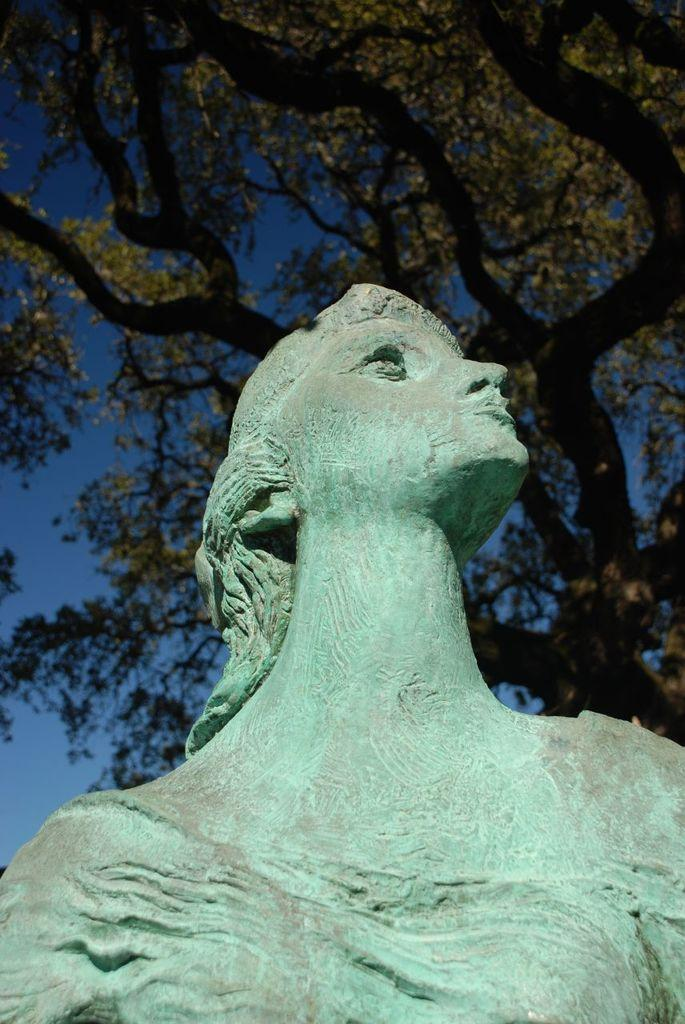What is the main subject in the image? There is a sculpture in the image. What can be seen in the background of the image? There is a tree in the background of the image. What color is the sky in the image? The sky is blue in the image. How many crows are sitting on the sculpture in the image? There are no crows present in the image; it only features a sculpture, a tree in the background, and a blue sky. 